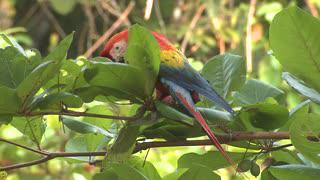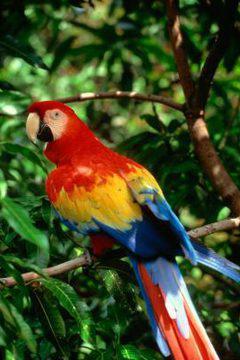The first image is the image on the left, the second image is the image on the right. For the images displayed, is the sentence "There are no more than three birds in the pair of images." factually correct? Answer yes or no. Yes. The first image is the image on the left, the second image is the image on the right. Evaluate the accuracy of this statement regarding the images: "All of the birds in the images are sitting in the branches of trees.". Is it true? Answer yes or no. Yes. 